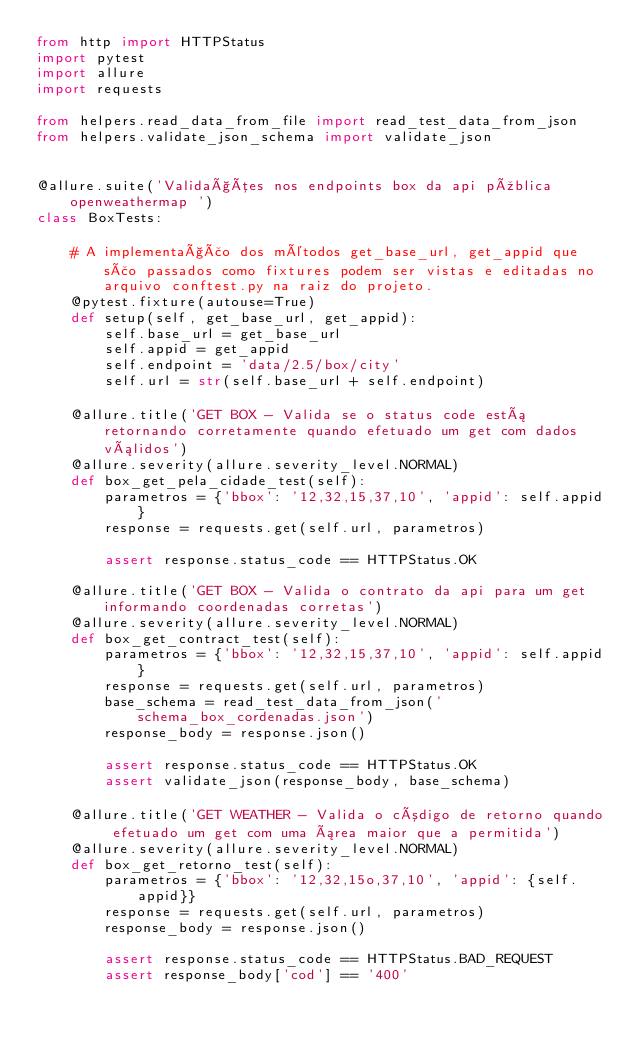<code> <loc_0><loc_0><loc_500><loc_500><_Python_>from http import HTTPStatus
import pytest
import allure
import requests

from helpers.read_data_from_file import read_test_data_from_json
from helpers.validate_json_schema import validate_json


@allure.suite('Validações nos endpoints box da api pública openweathermap ')
class BoxTests:

    # A implementação dos métodos get_base_url, get_appid que são passados como fixtures podem ser vistas e editadas no arquivo conftest.py na raiz do projeto.
    @pytest.fixture(autouse=True)
    def setup(self, get_base_url, get_appid):
        self.base_url = get_base_url
        self.appid = get_appid
        self.endpoint = 'data/2.5/box/city'
        self.url = str(self.base_url + self.endpoint)

    @allure.title('GET BOX - Valida se o status code está retornando corretamente quando efetuado um get com dados válidos')
    @allure.severity(allure.severity_level.NORMAL)
    def box_get_pela_cidade_test(self):
        parametros = {'bbox': '12,32,15,37,10', 'appid': self.appid}
        response = requests.get(self.url, parametros)

        assert response.status_code == HTTPStatus.OK

    @allure.title('GET BOX - Valida o contrato da api para um get informando coordenadas corretas')
    @allure.severity(allure.severity_level.NORMAL)
    def box_get_contract_test(self):
        parametros = {'bbox': '12,32,15,37,10', 'appid': self.appid}
        response = requests.get(self.url, parametros)
        base_schema = read_test_data_from_json('schema_box_cordenadas.json')
        response_body = response.json()

        assert response.status_code == HTTPStatus.OK
        assert validate_json(response_body, base_schema)

    @allure.title('GET WEATHER - Valida o código de retorno quando efetuado um get com uma área maior que a permitida')
    @allure.severity(allure.severity_level.NORMAL)
    def box_get_retorno_test(self):
        parametros = {'bbox': '12,32,15o,37,10', 'appid': {self.appid}}
        response = requests.get(self.url, parametros)
        response_body = response.json()

        assert response.status_code == HTTPStatus.BAD_REQUEST
        assert response_body['cod'] == '400'
</code> 